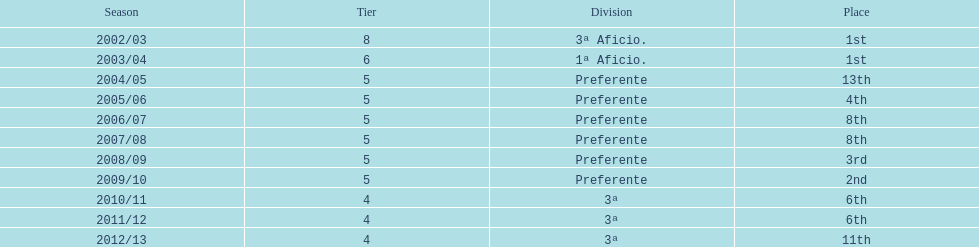Can you give me this table as a dict? {'header': ['Season', 'Tier', 'Division', 'Place'], 'rows': [['2002/03', '8', '3ª Aficio.', '1st'], ['2003/04', '6', '1ª Aficio.', '1st'], ['2004/05', '5', 'Preferente', '13th'], ['2005/06', '5', 'Preferente', '4th'], ['2006/07', '5', 'Preferente', '8th'], ['2007/08', '5', 'Preferente', '8th'], ['2008/09', '5', 'Preferente', '3rd'], ['2009/10', '5', 'Preferente', '2nd'], ['2010/11', '4', '3ª', '6th'], ['2011/12', '4', '3ª', '6th'], ['2012/13', '4', '3ª', '11th']]} What was the number of wins for preferente? 6. 